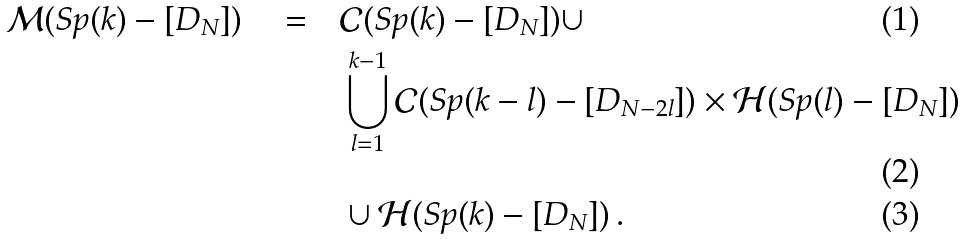<formula> <loc_0><loc_0><loc_500><loc_500>\mathcal { M } ( S p ( k ) - [ D _ { N } ] ) \quad = \quad & \mathcal { C } ( S p ( k ) - [ D _ { N } ] ) \cup \\ & \bigcup _ { l = 1 } ^ { k - 1 } \mathcal { C } ( S p ( k - l ) - [ D _ { N - 2 l } ] ) \times \mathcal { H } ( S p ( l ) - [ D _ { N } ] ) \\ & \cup \mathcal { H } ( S p ( k ) - [ D _ { N } ] ) \, .</formula> 